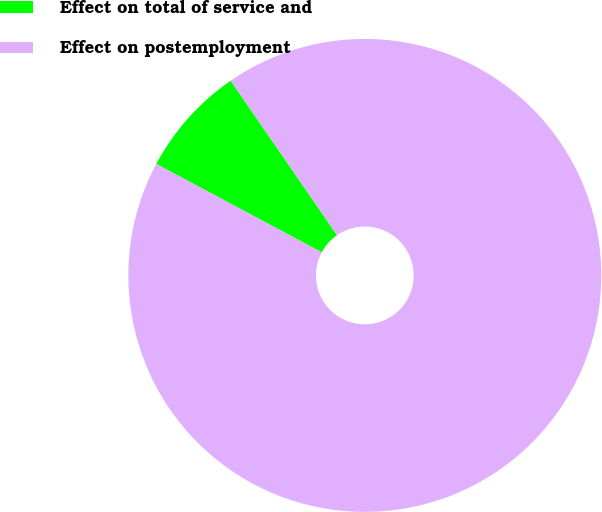<chart> <loc_0><loc_0><loc_500><loc_500><pie_chart><fcel>Effect on total of service and<fcel>Effect on postemployment<nl><fcel>7.59%<fcel>92.41%<nl></chart> 